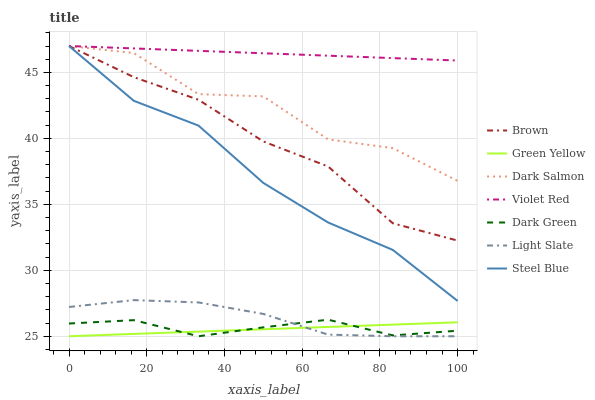Does Green Yellow have the minimum area under the curve?
Answer yes or no. Yes. Does Violet Red have the maximum area under the curve?
Answer yes or no. Yes. Does Light Slate have the minimum area under the curve?
Answer yes or no. No. Does Light Slate have the maximum area under the curve?
Answer yes or no. No. Is Green Yellow the smoothest?
Answer yes or no. Yes. Is Dark Salmon the roughest?
Answer yes or no. Yes. Is Violet Red the smoothest?
Answer yes or no. No. Is Violet Red the roughest?
Answer yes or no. No. Does Light Slate have the lowest value?
Answer yes or no. Yes. Does Violet Red have the lowest value?
Answer yes or no. No. Does Steel Blue have the highest value?
Answer yes or no. Yes. Does Light Slate have the highest value?
Answer yes or no. No. Is Green Yellow less than Steel Blue?
Answer yes or no. Yes. Is Dark Salmon greater than Dark Green?
Answer yes or no. Yes. Does Steel Blue intersect Brown?
Answer yes or no. Yes. Is Steel Blue less than Brown?
Answer yes or no. No. Is Steel Blue greater than Brown?
Answer yes or no. No. Does Green Yellow intersect Steel Blue?
Answer yes or no. No. 